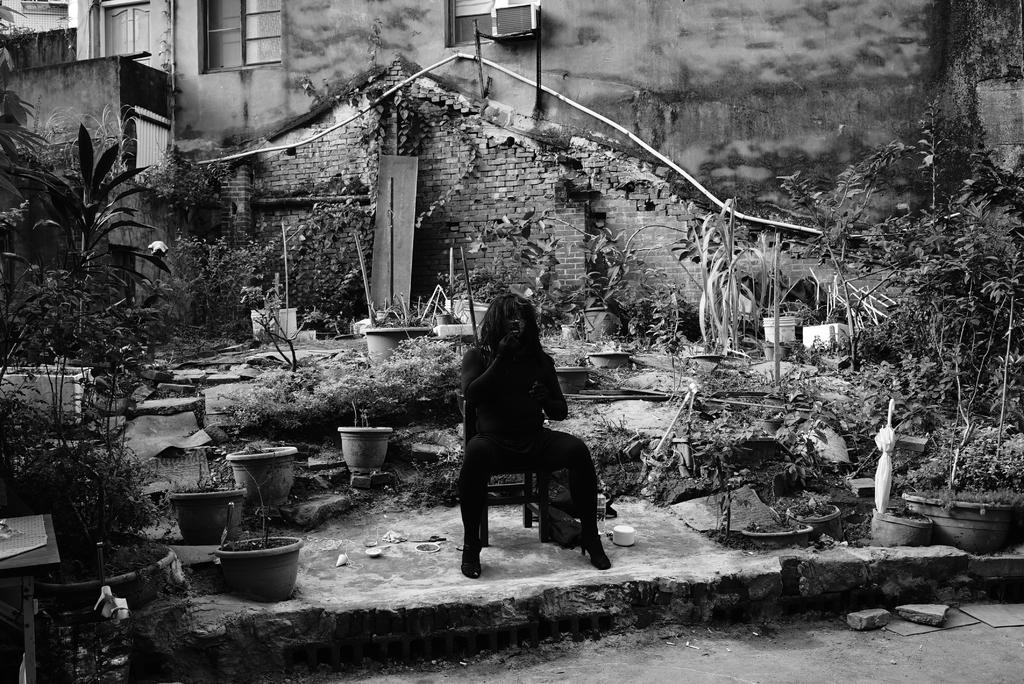How would you summarize this image in a sentence or two? This is a black and white image. I can see a person sitting on a chair. These are the flower pots with the plants in it. I can see the trees. This looks like a building with the windows. 